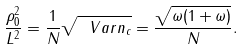Convert formula to latex. <formula><loc_0><loc_0><loc_500><loc_500>\frac { \rho _ { 0 } ^ { 2 } } { L ^ { 2 } } = \frac { 1 } { N } \sqrt { \ V a r n _ { c } } = \frac { \sqrt { \omega ( 1 + \omega ) } } { N } .</formula> 